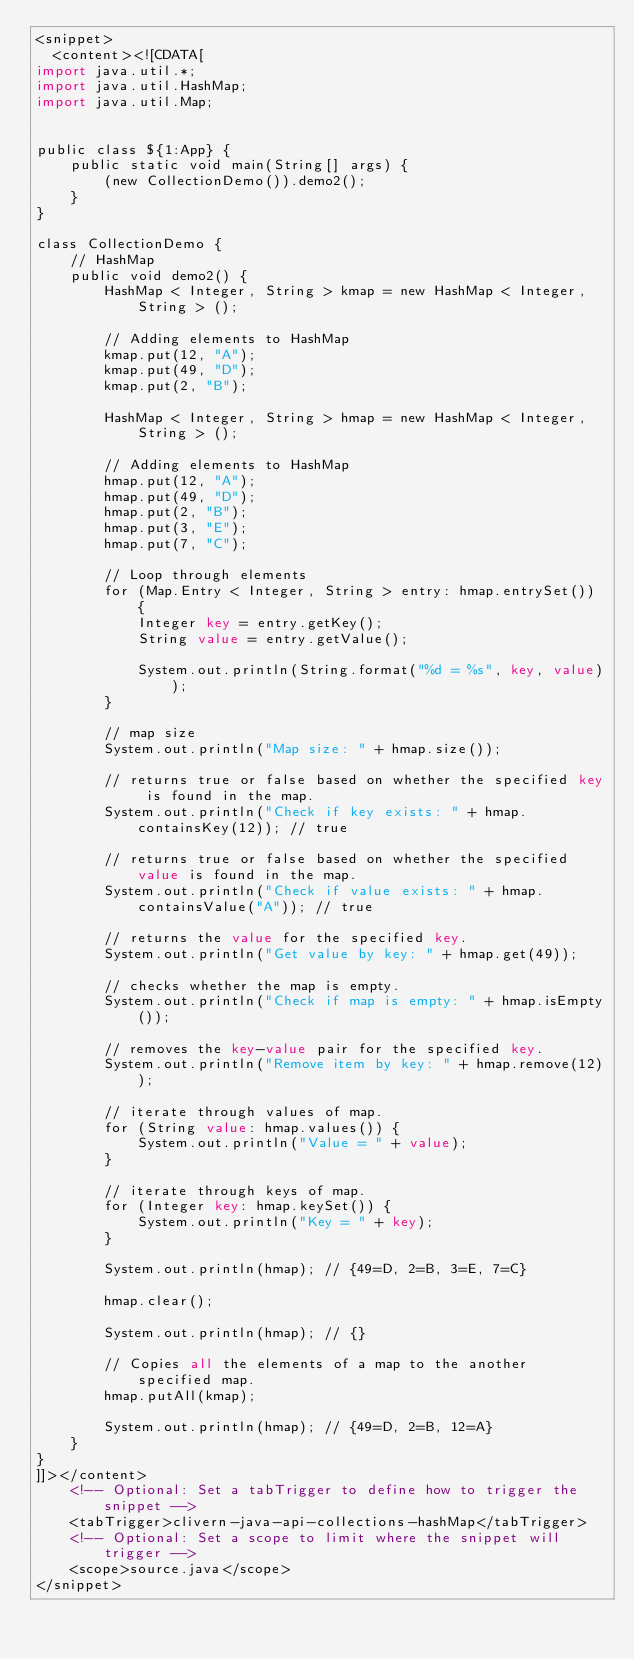<code> <loc_0><loc_0><loc_500><loc_500><_XML_><snippet>
  <content><![CDATA[
import java.util.*;
import java.util.HashMap;
import java.util.Map;


public class ${1:App} {
    public static void main(String[] args) {
        (new CollectionDemo()).demo2();
    }
}

class CollectionDemo {
    // HashMap
    public void demo2() {
        HashMap < Integer, String > kmap = new HashMap < Integer, String > ();

        // Adding elements to HashMap
        kmap.put(12, "A");
        kmap.put(49, "D");
        kmap.put(2, "B");

        HashMap < Integer, String > hmap = new HashMap < Integer, String > ();

        // Adding elements to HashMap
        hmap.put(12, "A");
        hmap.put(49, "D");
        hmap.put(2, "B");
        hmap.put(3, "E");
        hmap.put(7, "C");

        // Loop through elements
        for (Map.Entry < Integer, String > entry: hmap.entrySet()) {
            Integer key = entry.getKey();
            String value = entry.getValue();

            System.out.println(String.format("%d = %s", key, value));
        }

        // map size
        System.out.println("Map size: " + hmap.size());

        // returns true or false based on whether the specified key is found in the map.
        System.out.println("Check if key exists: " + hmap.containsKey(12)); // true

        // returns true or false based on whether the specified value is found in the map.
        System.out.println("Check if value exists: " + hmap.containsValue("A")); // true

        // returns the value for the specified key.
        System.out.println("Get value by key: " + hmap.get(49));

        // checks whether the map is empty.
        System.out.println("Check if map is empty: " + hmap.isEmpty());

        // removes the key-value pair for the specified key.
        System.out.println("Remove item by key: " + hmap.remove(12));

        // iterate through values of map.
        for (String value: hmap.values()) {
            System.out.println("Value = " + value);
        }

        // iterate through keys of map.
        for (Integer key: hmap.keySet()) {
            System.out.println("Key = " + key);
        }

        System.out.println(hmap); // {49=D, 2=B, 3=E, 7=C}

        hmap.clear();

        System.out.println(hmap); // {}

        // Copies all the elements of a map to the another specified map.
        hmap.putAll(kmap);

        System.out.println(hmap); // {49=D, 2=B, 12=A}
    }
}
]]></content>
    <!-- Optional: Set a tabTrigger to define how to trigger the snippet -->
    <tabTrigger>clivern-java-api-collections-hashMap</tabTrigger>
    <!-- Optional: Set a scope to limit where the snippet will trigger -->
    <scope>source.java</scope>
</snippet>
</code> 